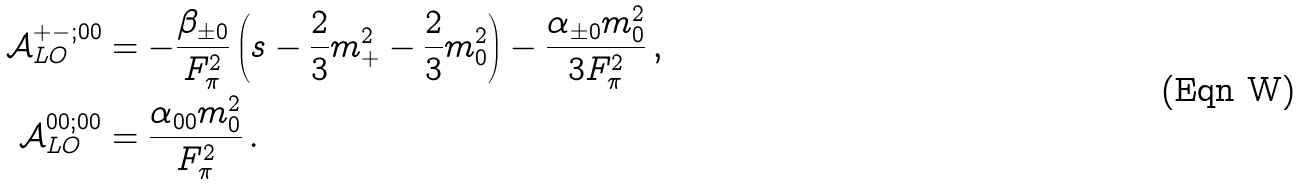<formula> <loc_0><loc_0><loc_500><loc_500>\mathcal { A } _ { L O } ^ { + - ; 0 0 } & = - \frac { \beta _ { \pm 0 } } { F _ { \pi } ^ { 2 } } \left ( s - \frac { 2 } { 3 } m _ { + } ^ { 2 } - \frac { 2 } { 3 } m _ { 0 } ^ { 2 } \right ) - \frac { \alpha _ { \pm 0 } m _ { 0 } ^ { 2 } } { 3 F _ { \pi } ^ { 2 } } \, , \\ \mathcal { A } _ { L O } ^ { 0 0 ; 0 0 } & = \frac { \alpha _ { 0 0 } m _ { 0 } ^ { 2 } } { F _ { \pi } ^ { 2 } } \, .</formula> 